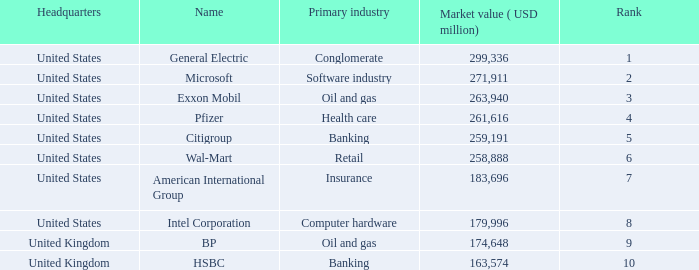How many ranks have an industry of health care? 1.0. 